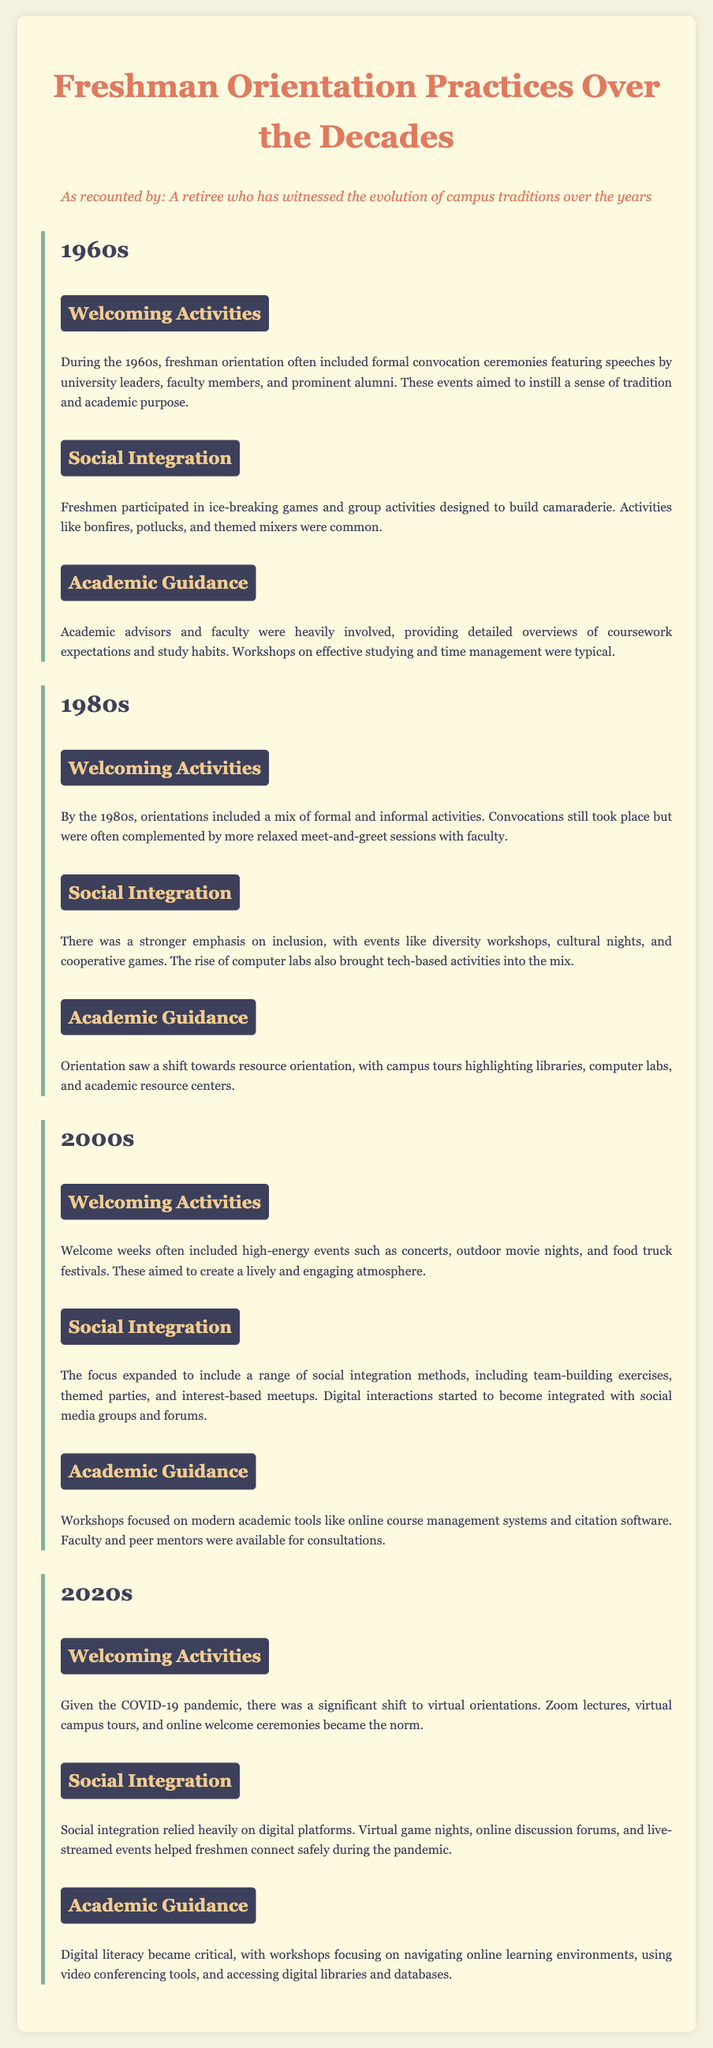What were common welcoming activities in the 1960s? The document specifies that formal convocation ceremonies with speeches by university leaders were common during the 1960s.
Answer: Convocation ceremonies What major shift occurred in orientation practices by the 1980s? The document indicates a shift towards more relaxed meet-and-greet sessions with faculty along with the continuation of convocations.
Answer: Relaxed meet-and-greet sessions Which decade introduced high-energy events like concerts and food truck festivals? The 2000s are described in the document as the decade where these high-energy events became part of orientation.
Answer: 2000s What type of activities were emphasized for social integration in the 1980s? The document mentions the emphasis on diversity workshops and cultural nights as part of social integration activities during that decade.
Answer: Diversity workshops What unique challenge did freshman orientation face in the 2020s? The document notes that the COVID-19 pandemic significantly shifted orientation practices, moving them online.
Answer: COVID-19 pandemic How did academic guidance evolve in the 2000s? The document states that workshops focused on modern academic tools like online course management systems during the 2000s.
Answer: Modern academic tools What was a common activity for freshmen in the 1960s? The document lists ice-breaking games as a common activity for freshmen during the 1960s orientation.
Answer: Ice-breaking games How did social integration change in the 2020s compared to previous decades? The document explains that social integration during the 2020s relied heavily on digital platforms due to the pandemic.
Answer: Digital platforms Which orientation practice highlighted campus resources in the 1980s? The document notes that campus tours highlighting libraries, computer labs, and academic resource centers became a focus in the 1980s.
Answer: Campus tours 